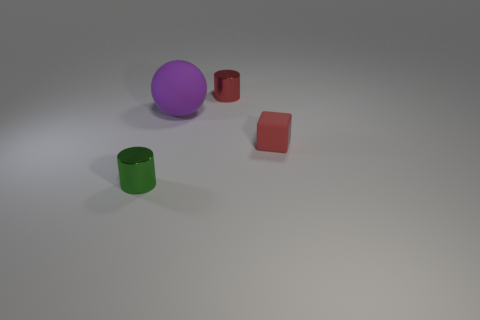Add 3 small gray things. How many objects exist? 7 Subtract 1 cylinders. How many cylinders are left? 1 Subtract all red spheres. How many green cylinders are left? 1 Add 4 big matte things. How many big matte things are left? 5 Add 4 purple objects. How many purple objects exist? 5 Subtract 1 purple spheres. How many objects are left? 3 Subtract all gray cylinders. Subtract all yellow spheres. How many cylinders are left? 2 Subtract all shiny cylinders. Subtract all large rubber balls. How many objects are left? 1 